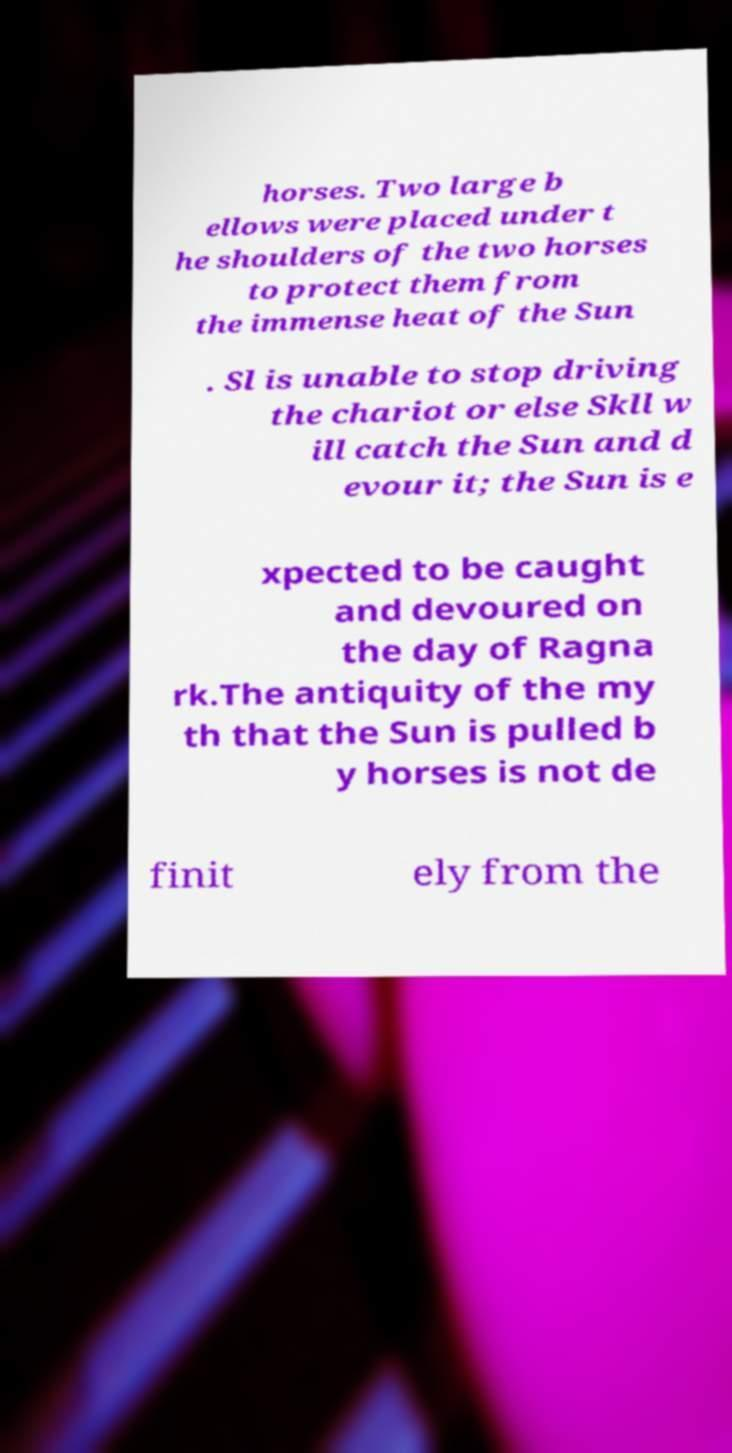Please read and relay the text visible in this image. What does it say? horses. Two large b ellows were placed under t he shoulders of the two horses to protect them from the immense heat of the Sun . Sl is unable to stop driving the chariot or else Skll w ill catch the Sun and d evour it; the Sun is e xpected to be caught and devoured on the day of Ragna rk.The antiquity of the my th that the Sun is pulled b y horses is not de finit ely from the 